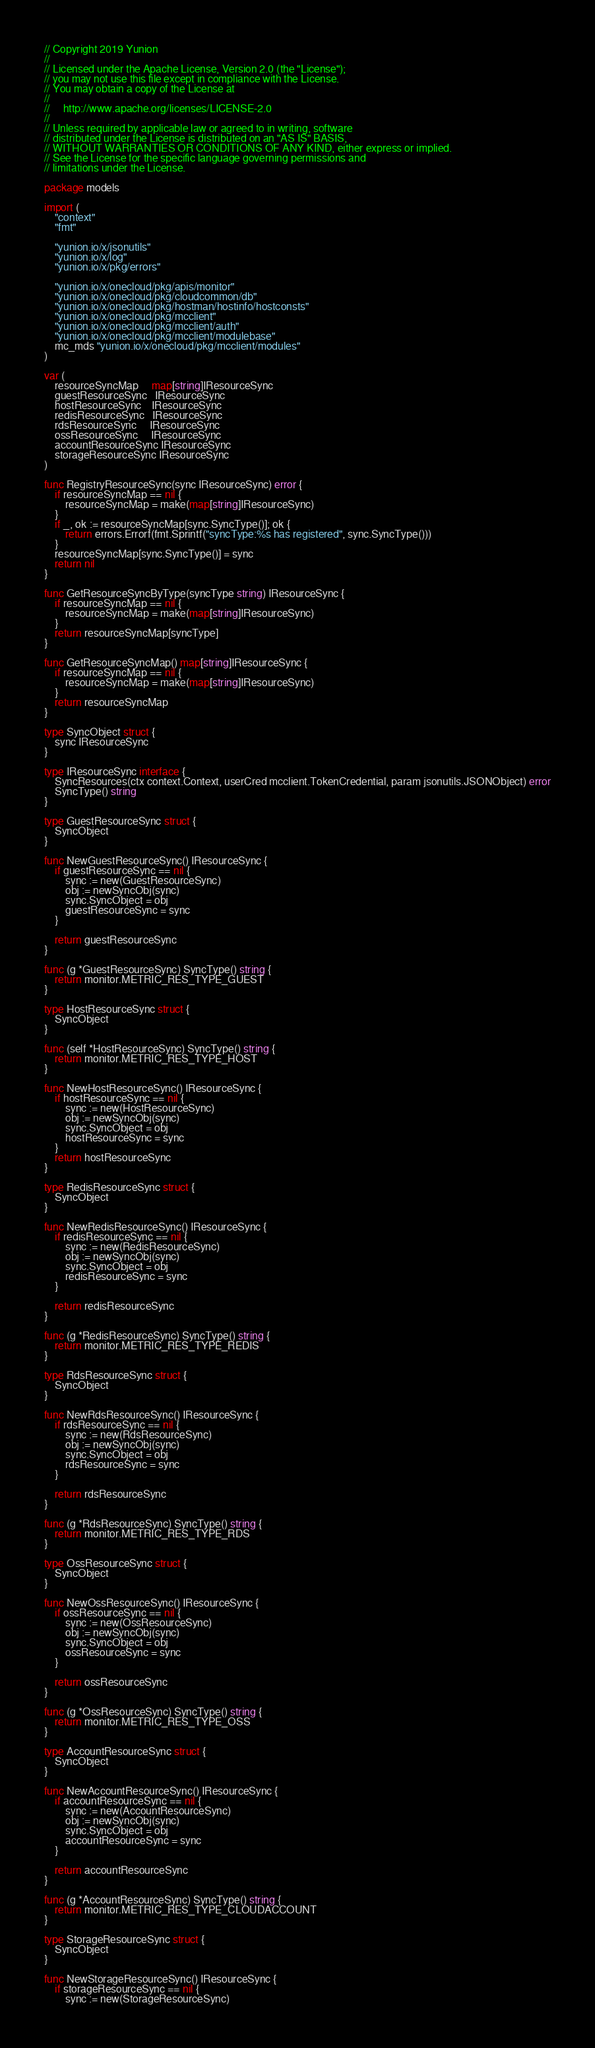<code> <loc_0><loc_0><loc_500><loc_500><_Go_>// Copyright 2019 Yunion
//
// Licensed under the Apache License, Version 2.0 (the "License");
// you may not use this file except in compliance with the License.
// You may obtain a copy of the License at
//
//     http://www.apache.org/licenses/LICENSE-2.0
//
// Unless required by applicable law or agreed to in writing, software
// distributed under the License is distributed on an "AS IS" BASIS,
// WITHOUT WARRANTIES OR CONDITIONS OF ANY KIND, either express or implied.
// See the License for the specific language governing permissions and
// limitations under the License.

package models

import (
	"context"
	"fmt"

	"yunion.io/x/jsonutils"
	"yunion.io/x/log"
	"yunion.io/x/pkg/errors"

	"yunion.io/x/onecloud/pkg/apis/monitor"
	"yunion.io/x/onecloud/pkg/cloudcommon/db"
	"yunion.io/x/onecloud/pkg/hostman/hostinfo/hostconsts"
	"yunion.io/x/onecloud/pkg/mcclient"
	"yunion.io/x/onecloud/pkg/mcclient/auth"
	"yunion.io/x/onecloud/pkg/mcclient/modulebase"
	mc_mds "yunion.io/x/onecloud/pkg/mcclient/modules"
)

var (
	resourceSyncMap     map[string]IResourceSync
	guestResourceSync   IResourceSync
	hostResourceSync    IResourceSync
	redisResourceSync   IResourceSync
	rdsResourceSync     IResourceSync
	ossResourceSync     IResourceSync
	accountResourceSync IResourceSync
	storageResourceSync IResourceSync
)

func RegistryResourceSync(sync IResourceSync) error {
	if resourceSyncMap == nil {
		resourceSyncMap = make(map[string]IResourceSync)
	}
	if _, ok := resourceSyncMap[sync.SyncType()]; ok {
		return errors.Errorf(fmt.Sprintf("syncType:%s has registered", sync.SyncType()))
	}
	resourceSyncMap[sync.SyncType()] = sync
	return nil
}

func GetResourceSyncByType(syncType string) IResourceSync {
	if resourceSyncMap == nil {
		resourceSyncMap = make(map[string]IResourceSync)
	}
	return resourceSyncMap[syncType]
}

func GetResourceSyncMap() map[string]IResourceSync {
	if resourceSyncMap == nil {
		resourceSyncMap = make(map[string]IResourceSync)
	}
	return resourceSyncMap
}

type SyncObject struct {
	sync IResourceSync
}

type IResourceSync interface {
	SyncResources(ctx context.Context, userCred mcclient.TokenCredential, param jsonutils.JSONObject) error
	SyncType() string
}

type GuestResourceSync struct {
	SyncObject
}

func NewGuestResourceSync() IResourceSync {
	if guestResourceSync == nil {
		sync := new(GuestResourceSync)
		obj := newSyncObj(sync)
		sync.SyncObject = obj
		guestResourceSync = sync
	}

	return guestResourceSync
}

func (g *GuestResourceSync) SyncType() string {
	return monitor.METRIC_RES_TYPE_GUEST
}

type HostResourceSync struct {
	SyncObject
}

func (self *HostResourceSync) SyncType() string {
	return monitor.METRIC_RES_TYPE_HOST
}

func NewHostResourceSync() IResourceSync {
	if hostResourceSync == nil {
		sync := new(HostResourceSync)
		obj := newSyncObj(sync)
		sync.SyncObject = obj
		hostResourceSync = sync
	}
	return hostResourceSync
}

type RedisResourceSync struct {
	SyncObject
}

func NewRedisResourceSync() IResourceSync {
	if redisResourceSync == nil {
		sync := new(RedisResourceSync)
		obj := newSyncObj(sync)
		sync.SyncObject = obj
		redisResourceSync = sync
	}

	return redisResourceSync
}

func (g *RedisResourceSync) SyncType() string {
	return monitor.METRIC_RES_TYPE_REDIS
}

type RdsResourceSync struct {
	SyncObject
}

func NewRdsResourceSync() IResourceSync {
	if rdsResourceSync == nil {
		sync := new(RdsResourceSync)
		obj := newSyncObj(sync)
		sync.SyncObject = obj
		rdsResourceSync = sync
	}

	return rdsResourceSync
}

func (g *RdsResourceSync) SyncType() string {
	return monitor.METRIC_RES_TYPE_RDS
}

type OssResourceSync struct {
	SyncObject
}

func NewOssResourceSync() IResourceSync {
	if ossResourceSync == nil {
		sync := new(OssResourceSync)
		obj := newSyncObj(sync)
		sync.SyncObject = obj
		ossResourceSync = sync
	}

	return ossResourceSync
}

func (g *OssResourceSync) SyncType() string {
	return monitor.METRIC_RES_TYPE_OSS
}

type AccountResourceSync struct {
	SyncObject
}

func NewAccountResourceSync() IResourceSync {
	if accountResourceSync == nil {
		sync := new(AccountResourceSync)
		obj := newSyncObj(sync)
		sync.SyncObject = obj
		accountResourceSync = sync
	}

	return accountResourceSync
}

func (g *AccountResourceSync) SyncType() string {
	return monitor.METRIC_RES_TYPE_CLOUDACCOUNT
}

type StorageResourceSync struct {
	SyncObject
}

func NewStorageResourceSync() IResourceSync {
	if storageResourceSync == nil {
		sync := new(StorageResourceSync)</code> 